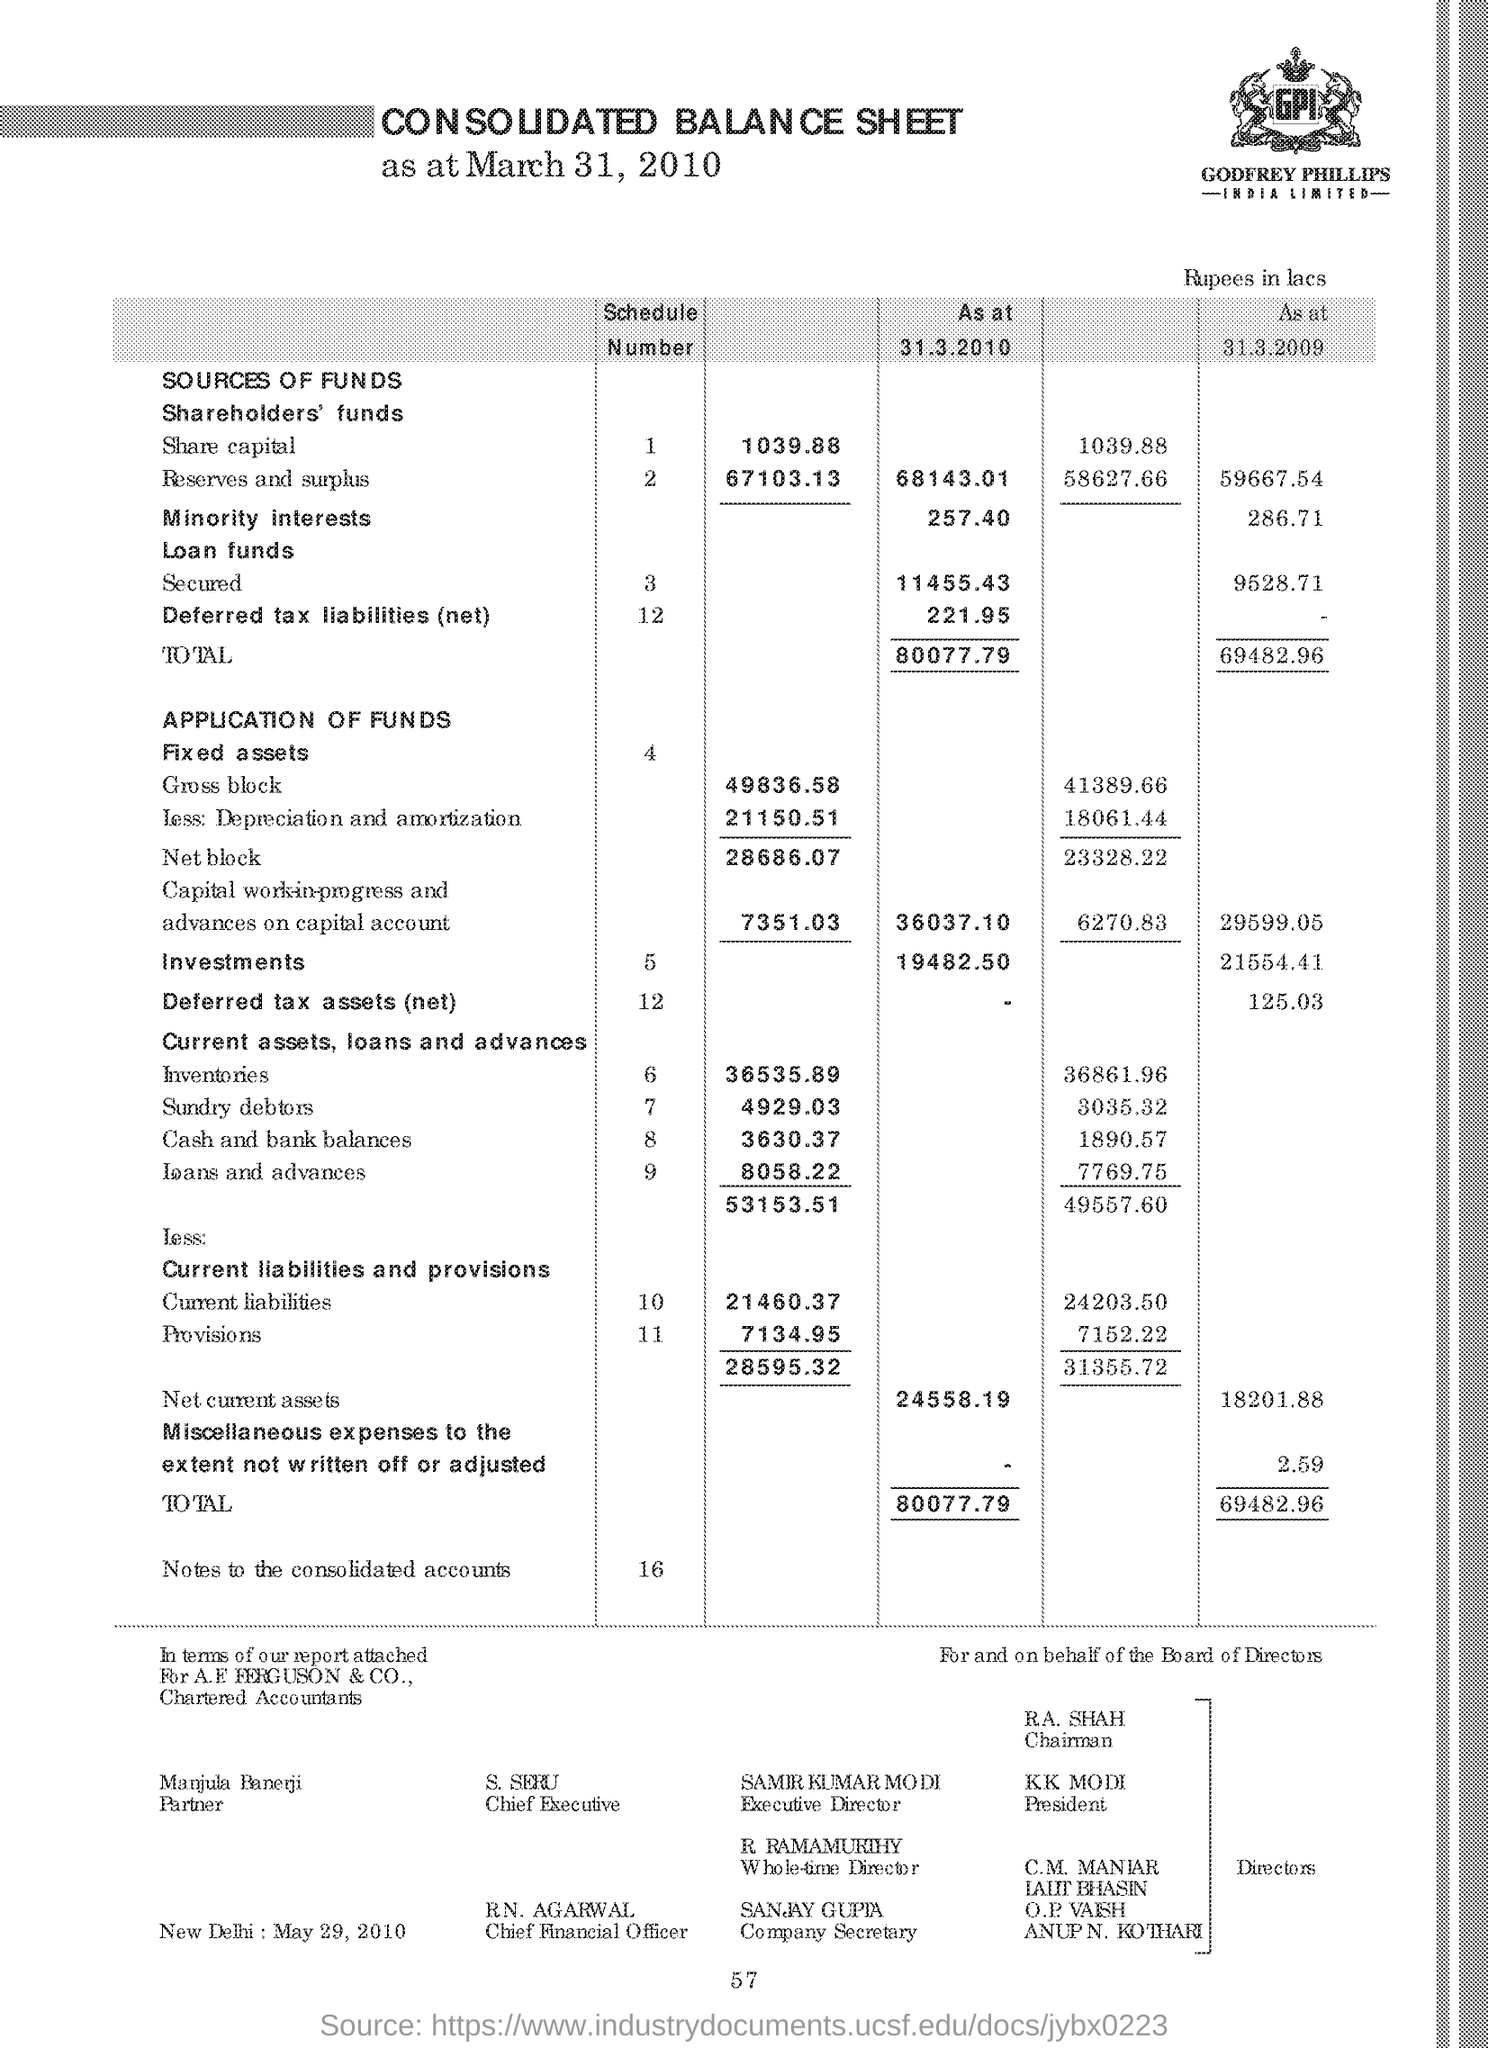Specify some key components in this picture. Manjula Banerji is the partner. R.A. SHAH is the chairman. R RamaMurthy is the whole time director. It is reported that the President is named KK Modi. The name of the company secretary is Sanjay Gupta. 